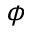<formula> <loc_0><loc_0><loc_500><loc_500>\phi</formula> 